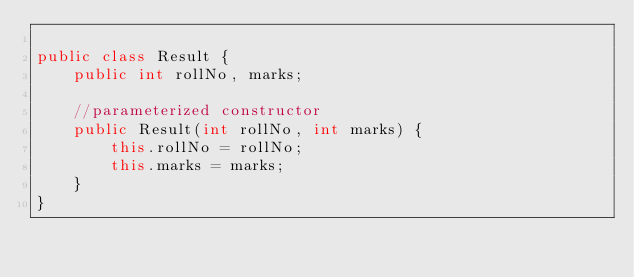Convert code to text. <code><loc_0><loc_0><loc_500><loc_500><_Java_>
public class Result {
    public int rollNo, marks;
    
    //parameterized constructor 
    public Result(int rollNo, int marks) {
        this.rollNo = rollNo;
        this.marks = marks;
    }
}</code> 